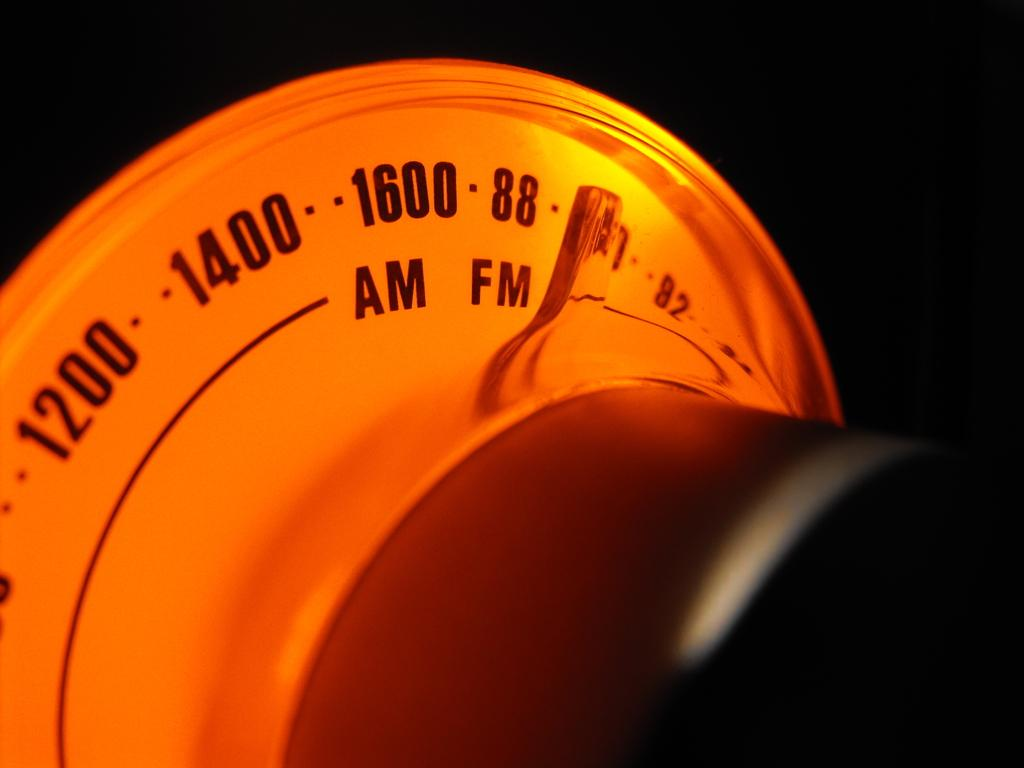What is the main subject of the image? The main subject of the image is a radio. What features does the radio have? The radio has AM and FM options. How many wishes can be granted by the radio in the image? There is no indication in the image that the radio has the ability to grant wishes, so it cannot be determined from the picture. 